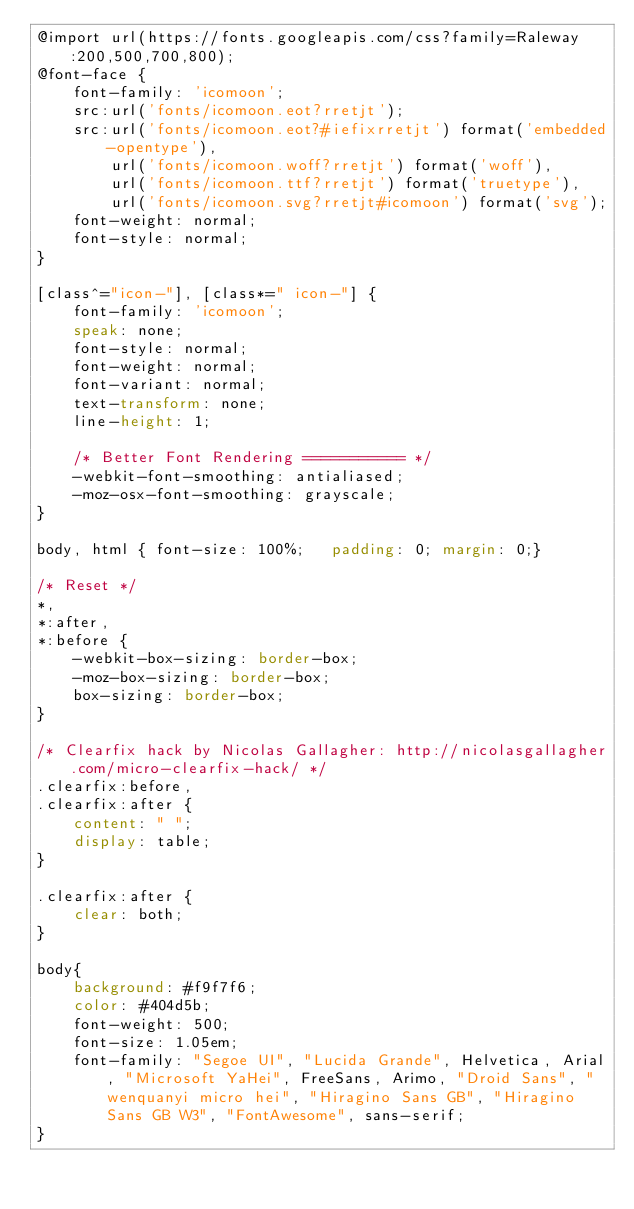<code> <loc_0><loc_0><loc_500><loc_500><_CSS_>@import url(https://fonts.googleapis.com/css?family=Raleway:200,500,700,800);
@font-face {
	font-family: 'icomoon';
	src:url('fonts/icomoon.eot?rretjt');
	src:url('fonts/icomoon.eot?#iefixrretjt') format('embedded-opentype'),
		url('fonts/icomoon.woff?rretjt') format('woff'),
		url('fonts/icomoon.ttf?rretjt') format('truetype'),
		url('fonts/icomoon.svg?rretjt#icomoon') format('svg');
	font-weight: normal;
	font-style: normal;
}

[class^="icon-"], [class*=" icon-"] {
	font-family: 'icomoon';
	speak: none;
	font-style: normal;
	font-weight: normal;
	font-variant: normal;
	text-transform: none;
	line-height: 1;

	/* Better Font Rendering =========== */
	-webkit-font-smoothing: antialiased;
	-moz-osx-font-smoothing: grayscale;
}

body, html { font-size: 100%; 	padding: 0; margin: 0;}

/* Reset */
*,
*:after,
*:before {
	-webkit-box-sizing: border-box;
	-moz-box-sizing: border-box;
	box-sizing: border-box;
}

/* Clearfix hack by Nicolas Gallagher: http://nicolasgallagher.com/micro-clearfix-hack/ */
.clearfix:before,
.clearfix:after {
	content: " ";
	display: table;
}

.clearfix:after {
	clear: both;
}

body{
	background: #f9f7f6;
	color: #404d5b;
	font-weight: 500;
	font-size: 1.05em;
	font-family: "Segoe UI", "Lucida Grande", Helvetica, Arial, "Microsoft YaHei", FreeSans, Arimo, "Droid Sans", "wenquanyi micro hei", "Hiragino Sans GB", "Hiragino Sans GB W3", "FontAwesome", sans-serif;
}</code> 